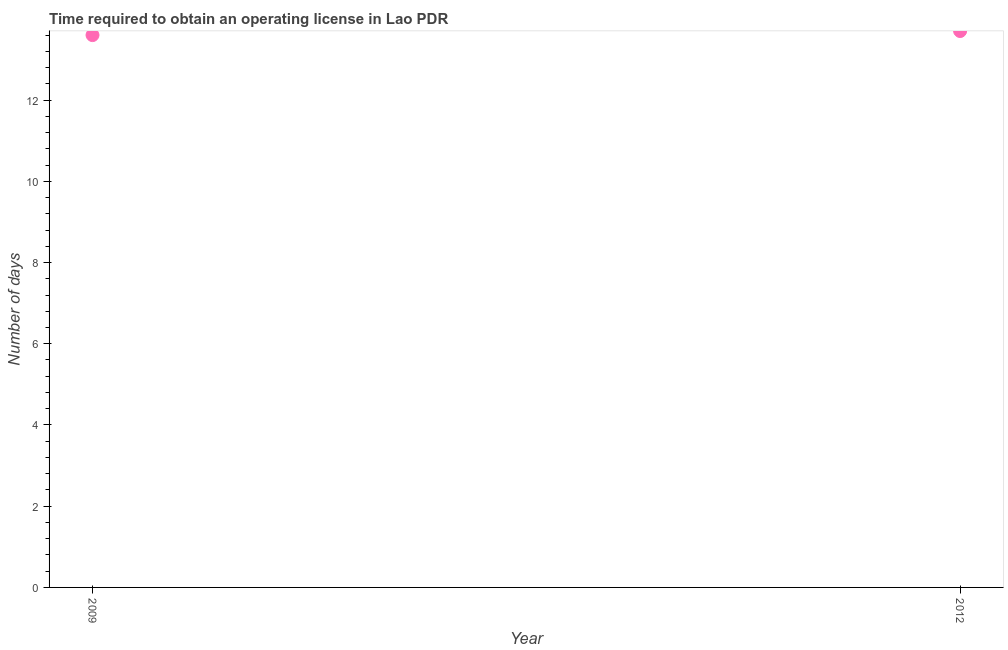Across all years, what is the minimum number of days to obtain operating license?
Provide a succinct answer. 13.6. In which year was the number of days to obtain operating license maximum?
Offer a very short reply. 2012. What is the sum of the number of days to obtain operating license?
Your answer should be very brief. 27.3. What is the difference between the number of days to obtain operating license in 2009 and 2012?
Make the answer very short. -0.1. What is the average number of days to obtain operating license per year?
Make the answer very short. 13.65. What is the median number of days to obtain operating license?
Keep it short and to the point. 13.65. In how many years, is the number of days to obtain operating license greater than 0.4 days?
Provide a short and direct response. 2. Do a majority of the years between 2009 and 2012 (inclusive) have number of days to obtain operating license greater than 12.4 days?
Make the answer very short. Yes. What is the ratio of the number of days to obtain operating license in 2009 to that in 2012?
Your answer should be compact. 0.99. What is the difference between two consecutive major ticks on the Y-axis?
Your response must be concise. 2. Are the values on the major ticks of Y-axis written in scientific E-notation?
Offer a very short reply. No. What is the title of the graph?
Keep it short and to the point. Time required to obtain an operating license in Lao PDR. What is the label or title of the X-axis?
Keep it short and to the point. Year. What is the label or title of the Y-axis?
Offer a terse response. Number of days. What is the Number of days in 2009?
Make the answer very short. 13.6. What is the Number of days in 2012?
Keep it short and to the point. 13.7. 